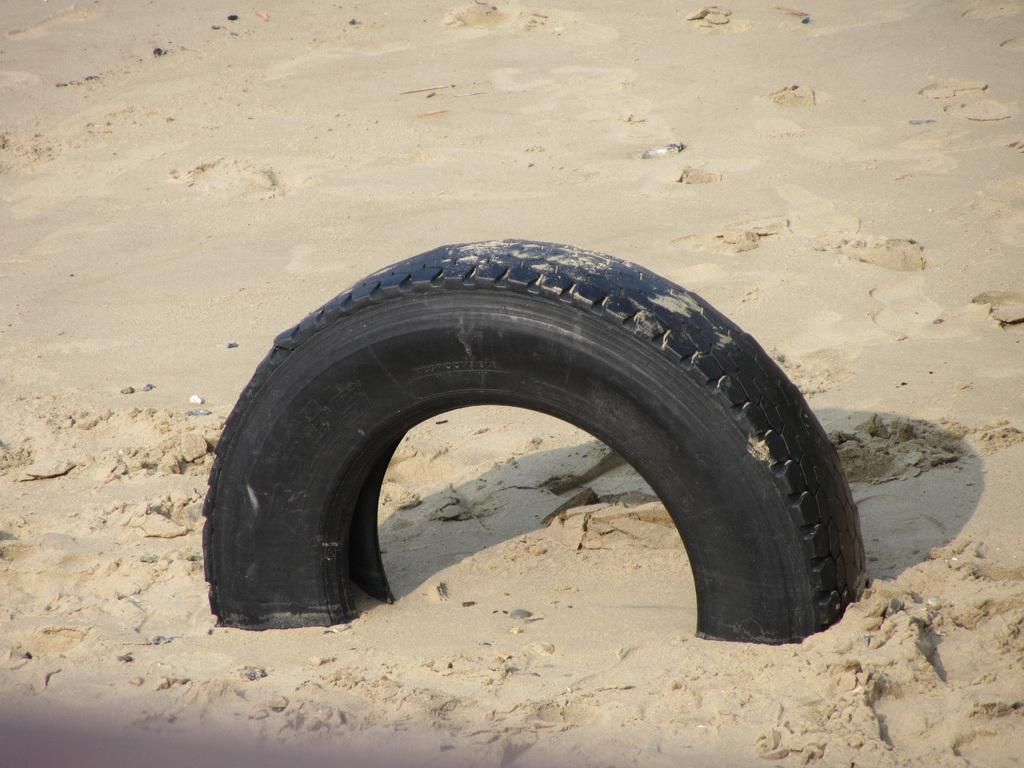What color is the tyre in the image? The tyre in the image is black. Where is the tyre located in the image? The tyre is inside the sand. What other elements can be seen in the image? There are small stones visible in the image. How many horses are running through the liquid in the image? There are no horses or liquid present in the image; it features a black tyre inside the sand with small stones visible. 